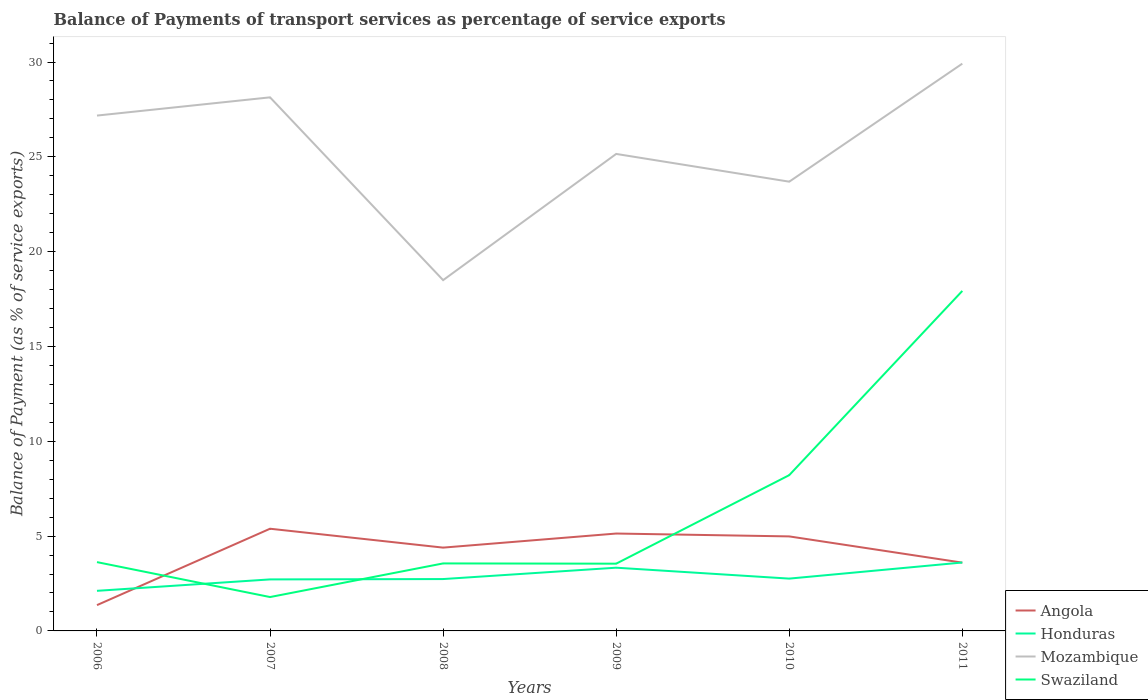How many different coloured lines are there?
Your response must be concise. 4. Across all years, what is the maximum balance of payments of transport services in Swaziland?
Offer a terse response. 1.79. What is the total balance of payments of transport services in Honduras in the graph?
Offer a terse response. 0.58. What is the difference between the highest and the second highest balance of payments of transport services in Swaziland?
Offer a terse response. 16.14. What is the difference between the highest and the lowest balance of payments of transport services in Swaziland?
Make the answer very short. 2. Is the balance of payments of transport services in Mozambique strictly greater than the balance of payments of transport services in Honduras over the years?
Make the answer very short. No. What is the difference between two consecutive major ticks on the Y-axis?
Make the answer very short. 5. Where does the legend appear in the graph?
Your answer should be compact. Bottom right. What is the title of the graph?
Your response must be concise. Balance of Payments of transport services as percentage of service exports. What is the label or title of the X-axis?
Make the answer very short. Years. What is the label or title of the Y-axis?
Give a very brief answer. Balance of Payment (as % of service exports). What is the Balance of Payment (as % of service exports) of Angola in 2006?
Your answer should be compact. 1.36. What is the Balance of Payment (as % of service exports) of Honduras in 2006?
Make the answer very short. 2.11. What is the Balance of Payment (as % of service exports) of Mozambique in 2006?
Provide a succinct answer. 27.18. What is the Balance of Payment (as % of service exports) of Swaziland in 2006?
Keep it short and to the point. 3.63. What is the Balance of Payment (as % of service exports) of Angola in 2007?
Give a very brief answer. 5.39. What is the Balance of Payment (as % of service exports) in Honduras in 2007?
Your answer should be very brief. 2.72. What is the Balance of Payment (as % of service exports) of Mozambique in 2007?
Offer a very short reply. 28.14. What is the Balance of Payment (as % of service exports) in Swaziland in 2007?
Your answer should be very brief. 1.79. What is the Balance of Payment (as % of service exports) of Angola in 2008?
Your response must be concise. 4.39. What is the Balance of Payment (as % of service exports) of Honduras in 2008?
Keep it short and to the point. 2.74. What is the Balance of Payment (as % of service exports) of Mozambique in 2008?
Provide a succinct answer. 18.5. What is the Balance of Payment (as % of service exports) in Swaziland in 2008?
Offer a very short reply. 3.56. What is the Balance of Payment (as % of service exports) in Angola in 2009?
Your answer should be compact. 5.14. What is the Balance of Payment (as % of service exports) in Honduras in 2009?
Give a very brief answer. 3.33. What is the Balance of Payment (as % of service exports) of Mozambique in 2009?
Your answer should be very brief. 25.15. What is the Balance of Payment (as % of service exports) in Swaziland in 2009?
Offer a terse response. 3.55. What is the Balance of Payment (as % of service exports) in Angola in 2010?
Offer a very short reply. 4.98. What is the Balance of Payment (as % of service exports) in Honduras in 2010?
Give a very brief answer. 2.76. What is the Balance of Payment (as % of service exports) in Mozambique in 2010?
Offer a terse response. 23.69. What is the Balance of Payment (as % of service exports) of Swaziland in 2010?
Offer a terse response. 8.22. What is the Balance of Payment (as % of service exports) in Angola in 2011?
Provide a succinct answer. 3.6. What is the Balance of Payment (as % of service exports) in Honduras in 2011?
Provide a short and direct response. 3.61. What is the Balance of Payment (as % of service exports) of Mozambique in 2011?
Your response must be concise. 29.91. What is the Balance of Payment (as % of service exports) of Swaziland in 2011?
Offer a very short reply. 17.93. Across all years, what is the maximum Balance of Payment (as % of service exports) in Angola?
Provide a succinct answer. 5.39. Across all years, what is the maximum Balance of Payment (as % of service exports) of Honduras?
Make the answer very short. 3.61. Across all years, what is the maximum Balance of Payment (as % of service exports) of Mozambique?
Provide a short and direct response. 29.91. Across all years, what is the maximum Balance of Payment (as % of service exports) in Swaziland?
Keep it short and to the point. 17.93. Across all years, what is the minimum Balance of Payment (as % of service exports) of Angola?
Give a very brief answer. 1.36. Across all years, what is the minimum Balance of Payment (as % of service exports) in Honduras?
Your answer should be very brief. 2.11. Across all years, what is the minimum Balance of Payment (as % of service exports) in Mozambique?
Offer a terse response. 18.5. Across all years, what is the minimum Balance of Payment (as % of service exports) in Swaziland?
Your answer should be very brief. 1.79. What is the total Balance of Payment (as % of service exports) in Angola in the graph?
Keep it short and to the point. 24.86. What is the total Balance of Payment (as % of service exports) of Honduras in the graph?
Offer a terse response. 17.27. What is the total Balance of Payment (as % of service exports) in Mozambique in the graph?
Ensure brevity in your answer.  152.57. What is the total Balance of Payment (as % of service exports) in Swaziland in the graph?
Make the answer very short. 38.67. What is the difference between the Balance of Payment (as % of service exports) in Angola in 2006 and that in 2007?
Give a very brief answer. -4.03. What is the difference between the Balance of Payment (as % of service exports) in Honduras in 2006 and that in 2007?
Your answer should be very brief. -0.6. What is the difference between the Balance of Payment (as % of service exports) in Mozambique in 2006 and that in 2007?
Keep it short and to the point. -0.96. What is the difference between the Balance of Payment (as % of service exports) of Swaziland in 2006 and that in 2007?
Your answer should be compact. 1.84. What is the difference between the Balance of Payment (as % of service exports) of Angola in 2006 and that in 2008?
Provide a succinct answer. -3.03. What is the difference between the Balance of Payment (as % of service exports) of Honduras in 2006 and that in 2008?
Your answer should be compact. -0.62. What is the difference between the Balance of Payment (as % of service exports) in Mozambique in 2006 and that in 2008?
Your response must be concise. 8.68. What is the difference between the Balance of Payment (as % of service exports) in Swaziland in 2006 and that in 2008?
Make the answer very short. 0.07. What is the difference between the Balance of Payment (as % of service exports) in Angola in 2006 and that in 2009?
Your answer should be compact. -3.77. What is the difference between the Balance of Payment (as % of service exports) of Honduras in 2006 and that in 2009?
Offer a very short reply. -1.22. What is the difference between the Balance of Payment (as % of service exports) of Mozambique in 2006 and that in 2009?
Offer a terse response. 2.02. What is the difference between the Balance of Payment (as % of service exports) of Swaziland in 2006 and that in 2009?
Offer a terse response. 0.08. What is the difference between the Balance of Payment (as % of service exports) of Angola in 2006 and that in 2010?
Offer a very short reply. -3.62. What is the difference between the Balance of Payment (as % of service exports) in Honduras in 2006 and that in 2010?
Provide a short and direct response. -0.64. What is the difference between the Balance of Payment (as % of service exports) of Mozambique in 2006 and that in 2010?
Offer a very short reply. 3.49. What is the difference between the Balance of Payment (as % of service exports) of Swaziland in 2006 and that in 2010?
Your response must be concise. -4.59. What is the difference between the Balance of Payment (as % of service exports) in Angola in 2006 and that in 2011?
Your answer should be very brief. -2.24. What is the difference between the Balance of Payment (as % of service exports) of Honduras in 2006 and that in 2011?
Offer a terse response. -1.49. What is the difference between the Balance of Payment (as % of service exports) of Mozambique in 2006 and that in 2011?
Your answer should be compact. -2.74. What is the difference between the Balance of Payment (as % of service exports) of Swaziland in 2006 and that in 2011?
Your answer should be compact. -14.3. What is the difference between the Balance of Payment (as % of service exports) of Angola in 2007 and that in 2008?
Keep it short and to the point. 1. What is the difference between the Balance of Payment (as % of service exports) of Honduras in 2007 and that in 2008?
Your response must be concise. -0.02. What is the difference between the Balance of Payment (as % of service exports) in Mozambique in 2007 and that in 2008?
Keep it short and to the point. 9.64. What is the difference between the Balance of Payment (as % of service exports) in Swaziland in 2007 and that in 2008?
Provide a succinct answer. -1.77. What is the difference between the Balance of Payment (as % of service exports) of Angola in 2007 and that in 2009?
Provide a succinct answer. 0.25. What is the difference between the Balance of Payment (as % of service exports) in Honduras in 2007 and that in 2009?
Give a very brief answer. -0.62. What is the difference between the Balance of Payment (as % of service exports) in Mozambique in 2007 and that in 2009?
Keep it short and to the point. 2.98. What is the difference between the Balance of Payment (as % of service exports) of Swaziland in 2007 and that in 2009?
Provide a succinct answer. -1.76. What is the difference between the Balance of Payment (as % of service exports) of Angola in 2007 and that in 2010?
Make the answer very short. 0.41. What is the difference between the Balance of Payment (as % of service exports) in Honduras in 2007 and that in 2010?
Make the answer very short. -0.04. What is the difference between the Balance of Payment (as % of service exports) in Mozambique in 2007 and that in 2010?
Your answer should be compact. 4.45. What is the difference between the Balance of Payment (as % of service exports) of Swaziland in 2007 and that in 2010?
Keep it short and to the point. -6.43. What is the difference between the Balance of Payment (as % of service exports) in Angola in 2007 and that in 2011?
Offer a very short reply. 1.79. What is the difference between the Balance of Payment (as % of service exports) in Honduras in 2007 and that in 2011?
Offer a terse response. -0.89. What is the difference between the Balance of Payment (as % of service exports) in Mozambique in 2007 and that in 2011?
Provide a short and direct response. -1.78. What is the difference between the Balance of Payment (as % of service exports) in Swaziland in 2007 and that in 2011?
Provide a short and direct response. -16.14. What is the difference between the Balance of Payment (as % of service exports) of Angola in 2008 and that in 2009?
Provide a short and direct response. -0.74. What is the difference between the Balance of Payment (as % of service exports) of Honduras in 2008 and that in 2009?
Keep it short and to the point. -0.6. What is the difference between the Balance of Payment (as % of service exports) of Mozambique in 2008 and that in 2009?
Provide a short and direct response. -6.66. What is the difference between the Balance of Payment (as % of service exports) of Swaziland in 2008 and that in 2009?
Offer a very short reply. 0.01. What is the difference between the Balance of Payment (as % of service exports) in Angola in 2008 and that in 2010?
Provide a short and direct response. -0.59. What is the difference between the Balance of Payment (as % of service exports) of Honduras in 2008 and that in 2010?
Keep it short and to the point. -0.02. What is the difference between the Balance of Payment (as % of service exports) of Mozambique in 2008 and that in 2010?
Make the answer very short. -5.19. What is the difference between the Balance of Payment (as % of service exports) in Swaziland in 2008 and that in 2010?
Provide a short and direct response. -4.66. What is the difference between the Balance of Payment (as % of service exports) of Angola in 2008 and that in 2011?
Your answer should be very brief. 0.79. What is the difference between the Balance of Payment (as % of service exports) in Honduras in 2008 and that in 2011?
Offer a terse response. -0.87. What is the difference between the Balance of Payment (as % of service exports) in Mozambique in 2008 and that in 2011?
Make the answer very short. -11.42. What is the difference between the Balance of Payment (as % of service exports) of Swaziland in 2008 and that in 2011?
Offer a terse response. -14.37. What is the difference between the Balance of Payment (as % of service exports) in Angola in 2009 and that in 2010?
Your answer should be compact. 0.15. What is the difference between the Balance of Payment (as % of service exports) of Honduras in 2009 and that in 2010?
Ensure brevity in your answer.  0.58. What is the difference between the Balance of Payment (as % of service exports) of Mozambique in 2009 and that in 2010?
Your answer should be very brief. 1.46. What is the difference between the Balance of Payment (as % of service exports) of Swaziland in 2009 and that in 2010?
Your answer should be compact. -4.67. What is the difference between the Balance of Payment (as % of service exports) in Angola in 2009 and that in 2011?
Make the answer very short. 1.53. What is the difference between the Balance of Payment (as % of service exports) in Honduras in 2009 and that in 2011?
Keep it short and to the point. -0.27. What is the difference between the Balance of Payment (as % of service exports) in Mozambique in 2009 and that in 2011?
Provide a short and direct response. -4.76. What is the difference between the Balance of Payment (as % of service exports) of Swaziland in 2009 and that in 2011?
Your answer should be very brief. -14.38. What is the difference between the Balance of Payment (as % of service exports) of Angola in 2010 and that in 2011?
Your response must be concise. 1.38. What is the difference between the Balance of Payment (as % of service exports) of Honduras in 2010 and that in 2011?
Give a very brief answer. -0.85. What is the difference between the Balance of Payment (as % of service exports) of Mozambique in 2010 and that in 2011?
Provide a short and direct response. -6.22. What is the difference between the Balance of Payment (as % of service exports) of Swaziland in 2010 and that in 2011?
Offer a very short reply. -9.71. What is the difference between the Balance of Payment (as % of service exports) of Angola in 2006 and the Balance of Payment (as % of service exports) of Honduras in 2007?
Your response must be concise. -1.36. What is the difference between the Balance of Payment (as % of service exports) of Angola in 2006 and the Balance of Payment (as % of service exports) of Mozambique in 2007?
Offer a very short reply. -26.78. What is the difference between the Balance of Payment (as % of service exports) of Angola in 2006 and the Balance of Payment (as % of service exports) of Swaziland in 2007?
Make the answer very short. -0.43. What is the difference between the Balance of Payment (as % of service exports) in Honduras in 2006 and the Balance of Payment (as % of service exports) in Mozambique in 2007?
Keep it short and to the point. -26.02. What is the difference between the Balance of Payment (as % of service exports) of Honduras in 2006 and the Balance of Payment (as % of service exports) of Swaziland in 2007?
Make the answer very short. 0.33. What is the difference between the Balance of Payment (as % of service exports) of Mozambique in 2006 and the Balance of Payment (as % of service exports) of Swaziland in 2007?
Offer a terse response. 25.39. What is the difference between the Balance of Payment (as % of service exports) of Angola in 2006 and the Balance of Payment (as % of service exports) of Honduras in 2008?
Your answer should be compact. -1.37. What is the difference between the Balance of Payment (as % of service exports) of Angola in 2006 and the Balance of Payment (as % of service exports) of Mozambique in 2008?
Keep it short and to the point. -17.14. What is the difference between the Balance of Payment (as % of service exports) in Angola in 2006 and the Balance of Payment (as % of service exports) in Swaziland in 2008?
Your answer should be compact. -2.2. What is the difference between the Balance of Payment (as % of service exports) in Honduras in 2006 and the Balance of Payment (as % of service exports) in Mozambique in 2008?
Provide a succinct answer. -16.38. What is the difference between the Balance of Payment (as % of service exports) in Honduras in 2006 and the Balance of Payment (as % of service exports) in Swaziland in 2008?
Offer a very short reply. -1.45. What is the difference between the Balance of Payment (as % of service exports) in Mozambique in 2006 and the Balance of Payment (as % of service exports) in Swaziland in 2008?
Offer a very short reply. 23.62. What is the difference between the Balance of Payment (as % of service exports) in Angola in 2006 and the Balance of Payment (as % of service exports) in Honduras in 2009?
Ensure brevity in your answer.  -1.97. What is the difference between the Balance of Payment (as % of service exports) in Angola in 2006 and the Balance of Payment (as % of service exports) in Mozambique in 2009?
Offer a very short reply. -23.79. What is the difference between the Balance of Payment (as % of service exports) of Angola in 2006 and the Balance of Payment (as % of service exports) of Swaziland in 2009?
Your answer should be compact. -2.19. What is the difference between the Balance of Payment (as % of service exports) in Honduras in 2006 and the Balance of Payment (as % of service exports) in Mozambique in 2009?
Offer a very short reply. -23.04. What is the difference between the Balance of Payment (as % of service exports) of Honduras in 2006 and the Balance of Payment (as % of service exports) of Swaziland in 2009?
Your response must be concise. -1.43. What is the difference between the Balance of Payment (as % of service exports) of Mozambique in 2006 and the Balance of Payment (as % of service exports) of Swaziland in 2009?
Offer a terse response. 23.63. What is the difference between the Balance of Payment (as % of service exports) in Angola in 2006 and the Balance of Payment (as % of service exports) in Honduras in 2010?
Provide a succinct answer. -1.4. What is the difference between the Balance of Payment (as % of service exports) in Angola in 2006 and the Balance of Payment (as % of service exports) in Mozambique in 2010?
Offer a terse response. -22.33. What is the difference between the Balance of Payment (as % of service exports) in Angola in 2006 and the Balance of Payment (as % of service exports) in Swaziland in 2010?
Make the answer very short. -6.85. What is the difference between the Balance of Payment (as % of service exports) of Honduras in 2006 and the Balance of Payment (as % of service exports) of Mozambique in 2010?
Ensure brevity in your answer.  -21.58. What is the difference between the Balance of Payment (as % of service exports) of Honduras in 2006 and the Balance of Payment (as % of service exports) of Swaziland in 2010?
Provide a succinct answer. -6.1. What is the difference between the Balance of Payment (as % of service exports) of Mozambique in 2006 and the Balance of Payment (as % of service exports) of Swaziland in 2010?
Your response must be concise. 18.96. What is the difference between the Balance of Payment (as % of service exports) in Angola in 2006 and the Balance of Payment (as % of service exports) in Honduras in 2011?
Keep it short and to the point. -2.25. What is the difference between the Balance of Payment (as % of service exports) of Angola in 2006 and the Balance of Payment (as % of service exports) of Mozambique in 2011?
Ensure brevity in your answer.  -28.55. What is the difference between the Balance of Payment (as % of service exports) of Angola in 2006 and the Balance of Payment (as % of service exports) of Swaziland in 2011?
Give a very brief answer. -16.57. What is the difference between the Balance of Payment (as % of service exports) of Honduras in 2006 and the Balance of Payment (as % of service exports) of Mozambique in 2011?
Make the answer very short. -27.8. What is the difference between the Balance of Payment (as % of service exports) in Honduras in 2006 and the Balance of Payment (as % of service exports) in Swaziland in 2011?
Ensure brevity in your answer.  -15.82. What is the difference between the Balance of Payment (as % of service exports) of Mozambique in 2006 and the Balance of Payment (as % of service exports) of Swaziland in 2011?
Ensure brevity in your answer.  9.25. What is the difference between the Balance of Payment (as % of service exports) in Angola in 2007 and the Balance of Payment (as % of service exports) in Honduras in 2008?
Keep it short and to the point. 2.65. What is the difference between the Balance of Payment (as % of service exports) of Angola in 2007 and the Balance of Payment (as % of service exports) of Mozambique in 2008?
Ensure brevity in your answer.  -13.11. What is the difference between the Balance of Payment (as % of service exports) in Angola in 2007 and the Balance of Payment (as % of service exports) in Swaziland in 2008?
Offer a very short reply. 1.83. What is the difference between the Balance of Payment (as % of service exports) in Honduras in 2007 and the Balance of Payment (as % of service exports) in Mozambique in 2008?
Ensure brevity in your answer.  -15.78. What is the difference between the Balance of Payment (as % of service exports) of Honduras in 2007 and the Balance of Payment (as % of service exports) of Swaziland in 2008?
Give a very brief answer. -0.84. What is the difference between the Balance of Payment (as % of service exports) of Mozambique in 2007 and the Balance of Payment (as % of service exports) of Swaziland in 2008?
Your answer should be compact. 24.58. What is the difference between the Balance of Payment (as % of service exports) of Angola in 2007 and the Balance of Payment (as % of service exports) of Honduras in 2009?
Your response must be concise. 2.06. What is the difference between the Balance of Payment (as % of service exports) of Angola in 2007 and the Balance of Payment (as % of service exports) of Mozambique in 2009?
Give a very brief answer. -19.76. What is the difference between the Balance of Payment (as % of service exports) of Angola in 2007 and the Balance of Payment (as % of service exports) of Swaziland in 2009?
Provide a succinct answer. 1.84. What is the difference between the Balance of Payment (as % of service exports) in Honduras in 2007 and the Balance of Payment (as % of service exports) in Mozambique in 2009?
Provide a succinct answer. -22.44. What is the difference between the Balance of Payment (as % of service exports) in Honduras in 2007 and the Balance of Payment (as % of service exports) in Swaziland in 2009?
Offer a terse response. -0.83. What is the difference between the Balance of Payment (as % of service exports) of Mozambique in 2007 and the Balance of Payment (as % of service exports) of Swaziland in 2009?
Offer a terse response. 24.59. What is the difference between the Balance of Payment (as % of service exports) of Angola in 2007 and the Balance of Payment (as % of service exports) of Honduras in 2010?
Give a very brief answer. 2.63. What is the difference between the Balance of Payment (as % of service exports) in Angola in 2007 and the Balance of Payment (as % of service exports) in Mozambique in 2010?
Provide a succinct answer. -18.3. What is the difference between the Balance of Payment (as % of service exports) in Angola in 2007 and the Balance of Payment (as % of service exports) in Swaziland in 2010?
Your response must be concise. -2.83. What is the difference between the Balance of Payment (as % of service exports) in Honduras in 2007 and the Balance of Payment (as % of service exports) in Mozambique in 2010?
Make the answer very short. -20.97. What is the difference between the Balance of Payment (as % of service exports) of Honduras in 2007 and the Balance of Payment (as % of service exports) of Swaziland in 2010?
Your answer should be compact. -5.5. What is the difference between the Balance of Payment (as % of service exports) in Mozambique in 2007 and the Balance of Payment (as % of service exports) in Swaziland in 2010?
Your response must be concise. 19.92. What is the difference between the Balance of Payment (as % of service exports) of Angola in 2007 and the Balance of Payment (as % of service exports) of Honduras in 2011?
Offer a terse response. 1.78. What is the difference between the Balance of Payment (as % of service exports) of Angola in 2007 and the Balance of Payment (as % of service exports) of Mozambique in 2011?
Your response must be concise. -24.53. What is the difference between the Balance of Payment (as % of service exports) in Angola in 2007 and the Balance of Payment (as % of service exports) in Swaziland in 2011?
Make the answer very short. -12.54. What is the difference between the Balance of Payment (as % of service exports) of Honduras in 2007 and the Balance of Payment (as % of service exports) of Mozambique in 2011?
Your answer should be very brief. -27.2. What is the difference between the Balance of Payment (as % of service exports) of Honduras in 2007 and the Balance of Payment (as % of service exports) of Swaziland in 2011?
Provide a short and direct response. -15.21. What is the difference between the Balance of Payment (as % of service exports) of Mozambique in 2007 and the Balance of Payment (as % of service exports) of Swaziland in 2011?
Make the answer very short. 10.21. What is the difference between the Balance of Payment (as % of service exports) in Angola in 2008 and the Balance of Payment (as % of service exports) in Honduras in 2009?
Give a very brief answer. 1.06. What is the difference between the Balance of Payment (as % of service exports) in Angola in 2008 and the Balance of Payment (as % of service exports) in Mozambique in 2009?
Your answer should be very brief. -20.76. What is the difference between the Balance of Payment (as % of service exports) in Angola in 2008 and the Balance of Payment (as % of service exports) in Swaziland in 2009?
Ensure brevity in your answer.  0.85. What is the difference between the Balance of Payment (as % of service exports) in Honduras in 2008 and the Balance of Payment (as % of service exports) in Mozambique in 2009?
Offer a very short reply. -22.42. What is the difference between the Balance of Payment (as % of service exports) in Honduras in 2008 and the Balance of Payment (as % of service exports) in Swaziland in 2009?
Your answer should be very brief. -0.81. What is the difference between the Balance of Payment (as % of service exports) of Mozambique in 2008 and the Balance of Payment (as % of service exports) of Swaziland in 2009?
Ensure brevity in your answer.  14.95. What is the difference between the Balance of Payment (as % of service exports) of Angola in 2008 and the Balance of Payment (as % of service exports) of Honduras in 2010?
Give a very brief answer. 1.63. What is the difference between the Balance of Payment (as % of service exports) in Angola in 2008 and the Balance of Payment (as % of service exports) in Mozambique in 2010?
Your response must be concise. -19.3. What is the difference between the Balance of Payment (as % of service exports) of Angola in 2008 and the Balance of Payment (as % of service exports) of Swaziland in 2010?
Ensure brevity in your answer.  -3.82. What is the difference between the Balance of Payment (as % of service exports) in Honduras in 2008 and the Balance of Payment (as % of service exports) in Mozambique in 2010?
Your response must be concise. -20.96. What is the difference between the Balance of Payment (as % of service exports) of Honduras in 2008 and the Balance of Payment (as % of service exports) of Swaziland in 2010?
Make the answer very short. -5.48. What is the difference between the Balance of Payment (as % of service exports) in Mozambique in 2008 and the Balance of Payment (as % of service exports) in Swaziland in 2010?
Ensure brevity in your answer.  10.28. What is the difference between the Balance of Payment (as % of service exports) of Angola in 2008 and the Balance of Payment (as % of service exports) of Honduras in 2011?
Provide a succinct answer. 0.79. What is the difference between the Balance of Payment (as % of service exports) of Angola in 2008 and the Balance of Payment (as % of service exports) of Mozambique in 2011?
Offer a terse response. -25.52. What is the difference between the Balance of Payment (as % of service exports) of Angola in 2008 and the Balance of Payment (as % of service exports) of Swaziland in 2011?
Make the answer very short. -13.54. What is the difference between the Balance of Payment (as % of service exports) of Honduras in 2008 and the Balance of Payment (as % of service exports) of Mozambique in 2011?
Provide a short and direct response. -27.18. What is the difference between the Balance of Payment (as % of service exports) of Honduras in 2008 and the Balance of Payment (as % of service exports) of Swaziland in 2011?
Ensure brevity in your answer.  -15.19. What is the difference between the Balance of Payment (as % of service exports) in Mozambique in 2008 and the Balance of Payment (as % of service exports) in Swaziland in 2011?
Provide a succinct answer. 0.57. What is the difference between the Balance of Payment (as % of service exports) of Angola in 2009 and the Balance of Payment (as % of service exports) of Honduras in 2010?
Your answer should be compact. 2.38. What is the difference between the Balance of Payment (as % of service exports) of Angola in 2009 and the Balance of Payment (as % of service exports) of Mozambique in 2010?
Provide a short and direct response. -18.56. What is the difference between the Balance of Payment (as % of service exports) of Angola in 2009 and the Balance of Payment (as % of service exports) of Swaziland in 2010?
Your answer should be compact. -3.08. What is the difference between the Balance of Payment (as % of service exports) of Honduras in 2009 and the Balance of Payment (as % of service exports) of Mozambique in 2010?
Give a very brief answer. -20.36. What is the difference between the Balance of Payment (as % of service exports) of Honduras in 2009 and the Balance of Payment (as % of service exports) of Swaziland in 2010?
Offer a very short reply. -4.88. What is the difference between the Balance of Payment (as % of service exports) of Mozambique in 2009 and the Balance of Payment (as % of service exports) of Swaziland in 2010?
Ensure brevity in your answer.  16.94. What is the difference between the Balance of Payment (as % of service exports) of Angola in 2009 and the Balance of Payment (as % of service exports) of Honduras in 2011?
Make the answer very short. 1.53. What is the difference between the Balance of Payment (as % of service exports) in Angola in 2009 and the Balance of Payment (as % of service exports) in Mozambique in 2011?
Give a very brief answer. -24.78. What is the difference between the Balance of Payment (as % of service exports) in Angola in 2009 and the Balance of Payment (as % of service exports) in Swaziland in 2011?
Your answer should be compact. -12.79. What is the difference between the Balance of Payment (as % of service exports) in Honduras in 2009 and the Balance of Payment (as % of service exports) in Mozambique in 2011?
Provide a short and direct response. -26.58. What is the difference between the Balance of Payment (as % of service exports) in Honduras in 2009 and the Balance of Payment (as % of service exports) in Swaziland in 2011?
Provide a succinct answer. -14.6. What is the difference between the Balance of Payment (as % of service exports) in Mozambique in 2009 and the Balance of Payment (as % of service exports) in Swaziland in 2011?
Provide a succinct answer. 7.22. What is the difference between the Balance of Payment (as % of service exports) in Angola in 2010 and the Balance of Payment (as % of service exports) in Honduras in 2011?
Ensure brevity in your answer.  1.38. What is the difference between the Balance of Payment (as % of service exports) in Angola in 2010 and the Balance of Payment (as % of service exports) in Mozambique in 2011?
Make the answer very short. -24.93. What is the difference between the Balance of Payment (as % of service exports) in Angola in 2010 and the Balance of Payment (as % of service exports) in Swaziland in 2011?
Make the answer very short. -12.95. What is the difference between the Balance of Payment (as % of service exports) in Honduras in 2010 and the Balance of Payment (as % of service exports) in Mozambique in 2011?
Provide a short and direct response. -27.16. What is the difference between the Balance of Payment (as % of service exports) in Honduras in 2010 and the Balance of Payment (as % of service exports) in Swaziland in 2011?
Ensure brevity in your answer.  -15.17. What is the difference between the Balance of Payment (as % of service exports) in Mozambique in 2010 and the Balance of Payment (as % of service exports) in Swaziland in 2011?
Make the answer very short. 5.76. What is the average Balance of Payment (as % of service exports) of Angola per year?
Give a very brief answer. 4.14. What is the average Balance of Payment (as % of service exports) in Honduras per year?
Keep it short and to the point. 2.88. What is the average Balance of Payment (as % of service exports) in Mozambique per year?
Your answer should be very brief. 25.43. What is the average Balance of Payment (as % of service exports) in Swaziland per year?
Your response must be concise. 6.44. In the year 2006, what is the difference between the Balance of Payment (as % of service exports) in Angola and Balance of Payment (as % of service exports) in Honduras?
Offer a very short reply. -0.75. In the year 2006, what is the difference between the Balance of Payment (as % of service exports) of Angola and Balance of Payment (as % of service exports) of Mozambique?
Provide a succinct answer. -25.82. In the year 2006, what is the difference between the Balance of Payment (as % of service exports) in Angola and Balance of Payment (as % of service exports) in Swaziland?
Ensure brevity in your answer.  -2.27. In the year 2006, what is the difference between the Balance of Payment (as % of service exports) of Honduras and Balance of Payment (as % of service exports) of Mozambique?
Ensure brevity in your answer.  -25.06. In the year 2006, what is the difference between the Balance of Payment (as % of service exports) in Honduras and Balance of Payment (as % of service exports) in Swaziland?
Provide a short and direct response. -1.51. In the year 2006, what is the difference between the Balance of Payment (as % of service exports) in Mozambique and Balance of Payment (as % of service exports) in Swaziland?
Keep it short and to the point. 23.55. In the year 2007, what is the difference between the Balance of Payment (as % of service exports) of Angola and Balance of Payment (as % of service exports) of Honduras?
Offer a very short reply. 2.67. In the year 2007, what is the difference between the Balance of Payment (as % of service exports) in Angola and Balance of Payment (as % of service exports) in Mozambique?
Provide a short and direct response. -22.75. In the year 2007, what is the difference between the Balance of Payment (as % of service exports) in Angola and Balance of Payment (as % of service exports) in Swaziland?
Provide a short and direct response. 3.6. In the year 2007, what is the difference between the Balance of Payment (as % of service exports) of Honduras and Balance of Payment (as % of service exports) of Mozambique?
Offer a very short reply. -25.42. In the year 2007, what is the difference between the Balance of Payment (as % of service exports) of Honduras and Balance of Payment (as % of service exports) of Swaziland?
Offer a very short reply. 0.93. In the year 2007, what is the difference between the Balance of Payment (as % of service exports) of Mozambique and Balance of Payment (as % of service exports) of Swaziland?
Your answer should be very brief. 26.35. In the year 2008, what is the difference between the Balance of Payment (as % of service exports) in Angola and Balance of Payment (as % of service exports) in Honduras?
Give a very brief answer. 1.66. In the year 2008, what is the difference between the Balance of Payment (as % of service exports) of Angola and Balance of Payment (as % of service exports) of Mozambique?
Offer a very short reply. -14.1. In the year 2008, what is the difference between the Balance of Payment (as % of service exports) in Angola and Balance of Payment (as % of service exports) in Swaziland?
Your answer should be compact. 0.83. In the year 2008, what is the difference between the Balance of Payment (as % of service exports) in Honduras and Balance of Payment (as % of service exports) in Mozambique?
Give a very brief answer. -15.76. In the year 2008, what is the difference between the Balance of Payment (as % of service exports) of Honduras and Balance of Payment (as % of service exports) of Swaziland?
Give a very brief answer. -0.82. In the year 2008, what is the difference between the Balance of Payment (as % of service exports) in Mozambique and Balance of Payment (as % of service exports) in Swaziland?
Your answer should be very brief. 14.94. In the year 2009, what is the difference between the Balance of Payment (as % of service exports) of Angola and Balance of Payment (as % of service exports) of Honduras?
Keep it short and to the point. 1.8. In the year 2009, what is the difference between the Balance of Payment (as % of service exports) in Angola and Balance of Payment (as % of service exports) in Mozambique?
Provide a succinct answer. -20.02. In the year 2009, what is the difference between the Balance of Payment (as % of service exports) in Angola and Balance of Payment (as % of service exports) in Swaziland?
Offer a terse response. 1.59. In the year 2009, what is the difference between the Balance of Payment (as % of service exports) in Honduras and Balance of Payment (as % of service exports) in Mozambique?
Offer a very short reply. -21.82. In the year 2009, what is the difference between the Balance of Payment (as % of service exports) in Honduras and Balance of Payment (as % of service exports) in Swaziland?
Offer a terse response. -0.21. In the year 2009, what is the difference between the Balance of Payment (as % of service exports) in Mozambique and Balance of Payment (as % of service exports) in Swaziland?
Your answer should be compact. 21.61. In the year 2010, what is the difference between the Balance of Payment (as % of service exports) of Angola and Balance of Payment (as % of service exports) of Honduras?
Offer a terse response. 2.23. In the year 2010, what is the difference between the Balance of Payment (as % of service exports) in Angola and Balance of Payment (as % of service exports) in Mozambique?
Keep it short and to the point. -18.71. In the year 2010, what is the difference between the Balance of Payment (as % of service exports) of Angola and Balance of Payment (as % of service exports) of Swaziland?
Your answer should be compact. -3.23. In the year 2010, what is the difference between the Balance of Payment (as % of service exports) in Honduras and Balance of Payment (as % of service exports) in Mozambique?
Offer a terse response. -20.93. In the year 2010, what is the difference between the Balance of Payment (as % of service exports) in Honduras and Balance of Payment (as % of service exports) in Swaziland?
Keep it short and to the point. -5.46. In the year 2010, what is the difference between the Balance of Payment (as % of service exports) of Mozambique and Balance of Payment (as % of service exports) of Swaziland?
Provide a short and direct response. 15.48. In the year 2011, what is the difference between the Balance of Payment (as % of service exports) in Angola and Balance of Payment (as % of service exports) in Honduras?
Your response must be concise. -0.01. In the year 2011, what is the difference between the Balance of Payment (as % of service exports) in Angola and Balance of Payment (as % of service exports) in Mozambique?
Provide a succinct answer. -26.31. In the year 2011, what is the difference between the Balance of Payment (as % of service exports) in Angola and Balance of Payment (as % of service exports) in Swaziland?
Your response must be concise. -14.33. In the year 2011, what is the difference between the Balance of Payment (as % of service exports) in Honduras and Balance of Payment (as % of service exports) in Mozambique?
Your answer should be compact. -26.31. In the year 2011, what is the difference between the Balance of Payment (as % of service exports) in Honduras and Balance of Payment (as % of service exports) in Swaziland?
Provide a short and direct response. -14.32. In the year 2011, what is the difference between the Balance of Payment (as % of service exports) in Mozambique and Balance of Payment (as % of service exports) in Swaziland?
Offer a very short reply. 11.98. What is the ratio of the Balance of Payment (as % of service exports) of Angola in 2006 to that in 2007?
Ensure brevity in your answer.  0.25. What is the ratio of the Balance of Payment (as % of service exports) of Honduras in 2006 to that in 2007?
Your answer should be very brief. 0.78. What is the ratio of the Balance of Payment (as % of service exports) of Mozambique in 2006 to that in 2007?
Your answer should be compact. 0.97. What is the ratio of the Balance of Payment (as % of service exports) of Swaziland in 2006 to that in 2007?
Keep it short and to the point. 2.03. What is the ratio of the Balance of Payment (as % of service exports) of Angola in 2006 to that in 2008?
Offer a very short reply. 0.31. What is the ratio of the Balance of Payment (as % of service exports) in Honduras in 2006 to that in 2008?
Offer a very short reply. 0.77. What is the ratio of the Balance of Payment (as % of service exports) of Mozambique in 2006 to that in 2008?
Give a very brief answer. 1.47. What is the ratio of the Balance of Payment (as % of service exports) in Swaziland in 2006 to that in 2008?
Your answer should be very brief. 1.02. What is the ratio of the Balance of Payment (as % of service exports) in Angola in 2006 to that in 2009?
Your response must be concise. 0.27. What is the ratio of the Balance of Payment (as % of service exports) of Honduras in 2006 to that in 2009?
Offer a very short reply. 0.63. What is the ratio of the Balance of Payment (as % of service exports) of Mozambique in 2006 to that in 2009?
Provide a short and direct response. 1.08. What is the ratio of the Balance of Payment (as % of service exports) in Swaziland in 2006 to that in 2009?
Keep it short and to the point. 1.02. What is the ratio of the Balance of Payment (as % of service exports) in Angola in 2006 to that in 2010?
Provide a short and direct response. 0.27. What is the ratio of the Balance of Payment (as % of service exports) of Honduras in 2006 to that in 2010?
Your answer should be very brief. 0.77. What is the ratio of the Balance of Payment (as % of service exports) of Mozambique in 2006 to that in 2010?
Your response must be concise. 1.15. What is the ratio of the Balance of Payment (as % of service exports) of Swaziland in 2006 to that in 2010?
Offer a very short reply. 0.44. What is the ratio of the Balance of Payment (as % of service exports) in Angola in 2006 to that in 2011?
Ensure brevity in your answer.  0.38. What is the ratio of the Balance of Payment (as % of service exports) in Honduras in 2006 to that in 2011?
Provide a succinct answer. 0.59. What is the ratio of the Balance of Payment (as % of service exports) in Mozambique in 2006 to that in 2011?
Your answer should be compact. 0.91. What is the ratio of the Balance of Payment (as % of service exports) of Swaziland in 2006 to that in 2011?
Give a very brief answer. 0.2. What is the ratio of the Balance of Payment (as % of service exports) of Angola in 2007 to that in 2008?
Ensure brevity in your answer.  1.23. What is the ratio of the Balance of Payment (as % of service exports) of Honduras in 2007 to that in 2008?
Provide a succinct answer. 0.99. What is the ratio of the Balance of Payment (as % of service exports) of Mozambique in 2007 to that in 2008?
Provide a short and direct response. 1.52. What is the ratio of the Balance of Payment (as % of service exports) of Swaziland in 2007 to that in 2008?
Your answer should be compact. 0.5. What is the ratio of the Balance of Payment (as % of service exports) of Angola in 2007 to that in 2009?
Offer a very short reply. 1.05. What is the ratio of the Balance of Payment (as % of service exports) in Honduras in 2007 to that in 2009?
Give a very brief answer. 0.81. What is the ratio of the Balance of Payment (as % of service exports) in Mozambique in 2007 to that in 2009?
Ensure brevity in your answer.  1.12. What is the ratio of the Balance of Payment (as % of service exports) in Swaziland in 2007 to that in 2009?
Offer a terse response. 0.5. What is the ratio of the Balance of Payment (as % of service exports) in Angola in 2007 to that in 2010?
Provide a succinct answer. 1.08. What is the ratio of the Balance of Payment (as % of service exports) of Honduras in 2007 to that in 2010?
Offer a very short reply. 0.98. What is the ratio of the Balance of Payment (as % of service exports) in Mozambique in 2007 to that in 2010?
Offer a very short reply. 1.19. What is the ratio of the Balance of Payment (as % of service exports) in Swaziland in 2007 to that in 2010?
Ensure brevity in your answer.  0.22. What is the ratio of the Balance of Payment (as % of service exports) of Angola in 2007 to that in 2011?
Provide a succinct answer. 1.5. What is the ratio of the Balance of Payment (as % of service exports) of Honduras in 2007 to that in 2011?
Offer a terse response. 0.75. What is the ratio of the Balance of Payment (as % of service exports) in Mozambique in 2007 to that in 2011?
Offer a very short reply. 0.94. What is the ratio of the Balance of Payment (as % of service exports) of Swaziland in 2007 to that in 2011?
Your answer should be very brief. 0.1. What is the ratio of the Balance of Payment (as % of service exports) of Angola in 2008 to that in 2009?
Provide a succinct answer. 0.86. What is the ratio of the Balance of Payment (as % of service exports) of Honduras in 2008 to that in 2009?
Keep it short and to the point. 0.82. What is the ratio of the Balance of Payment (as % of service exports) in Mozambique in 2008 to that in 2009?
Give a very brief answer. 0.74. What is the ratio of the Balance of Payment (as % of service exports) of Swaziland in 2008 to that in 2009?
Provide a succinct answer. 1. What is the ratio of the Balance of Payment (as % of service exports) of Angola in 2008 to that in 2010?
Ensure brevity in your answer.  0.88. What is the ratio of the Balance of Payment (as % of service exports) in Honduras in 2008 to that in 2010?
Ensure brevity in your answer.  0.99. What is the ratio of the Balance of Payment (as % of service exports) of Mozambique in 2008 to that in 2010?
Keep it short and to the point. 0.78. What is the ratio of the Balance of Payment (as % of service exports) in Swaziland in 2008 to that in 2010?
Your response must be concise. 0.43. What is the ratio of the Balance of Payment (as % of service exports) of Angola in 2008 to that in 2011?
Offer a terse response. 1.22. What is the ratio of the Balance of Payment (as % of service exports) of Honduras in 2008 to that in 2011?
Ensure brevity in your answer.  0.76. What is the ratio of the Balance of Payment (as % of service exports) of Mozambique in 2008 to that in 2011?
Provide a succinct answer. 0.62. What is the ratio of the Balance of Payment (as % of service exports) in Swaziland in 2008 to that in 2011?
Make the answer very short. 0.2. What is the ratio of the Balance of Payment (as % of service exports) in Angola in 2009 to that in 2010?
Keep it short and to the point. 1.03. What is the ratio of the Balance of Payment (as % of service exports) of Honduras in 2009 to that in 2010?
Give a very brief answer. 1.21. What is the ratio of the Balance of Payment (as % of service exports) of Mozambique in 2009 to that in 2010?
Keep it short and to the point. 1.06. What is the ratio of the Balance of Payment (as % of service exports) in Swaziland in 2009 to that in 2010?
Your response must be concise. 0.43. What is the ratio of the Balance of Payment (as % of service exports) in Angola in 2009 to that in 2011?
Give a very brief answer. 1.43. What is the ratio of the Balance of Payment (as % of service exports) of Honduras in 2009 to that in 2011?
Your answer should be compact. 0.92. What is the ratio of the Balance of Payment (as % of service exports) in Mozambique in 2009 to that in 2011?
Your answer should be compact. 0.84. What is the ratio of the Balance of Payment (as % of service exports) in Swaziland in 2009 to that in 2011?
Give a very brief answer. 0.2. What is the ratio of the Balance of Payment (as % of service exports) in Angola in 2010 to that in 2011?
Give a very brief answer. 1.38. What is the ratio of the Balance of Payment (as % of service exports) of Honduras in 2010 to that in 2011?
Your answer should be very brief. 0.76. What is the ratio of the Balance of Payment (as % of service exports) of Mozambique in 2010 to that in 2011?
Provide a short and direct response. 0.79. What is the ratio of the Balance of Payment (as % of service exports) of Swaziland in 2010 to that in 2011?
Offer a terse response. 0.46. What is the difference between the highest and the second highest Balance of Payment (as % of service exports) in Angola?
Give a very brief answer. 0.25. What is the difference between the highest and the second highest Balance of Payment (as % of service exports) of Honduras?
Keep it short and to the point. 0.27. What is the difference between the highest and the second highest Balance of Payment (as % of service exports) of Mozambique?
Offer a terse response. 1.78. What is the difference between the highest and the second highest Balance of Payment (as % of service exports) in Swaziland?
Your response must be concise. 9.71. What is the difference between the highest and the lowest Balance of Payment (as % of service exports) of Angola?
Provide a succinct answer. 4.03. What is the difference between the highest and the lowest Balance of Payment (as % of service exports) of Honduras?
Keep it short and to the point. 1.49. What is the difference between the highest and the lowest Balance of Payment (as % of service exports) of Mozambique?
Offer a terse response. 11.42. What is the difference between the highest and the lowest Balance of Payment (as % of service exports) in Swaziland?
Provide a short and direct response. 16.14. 